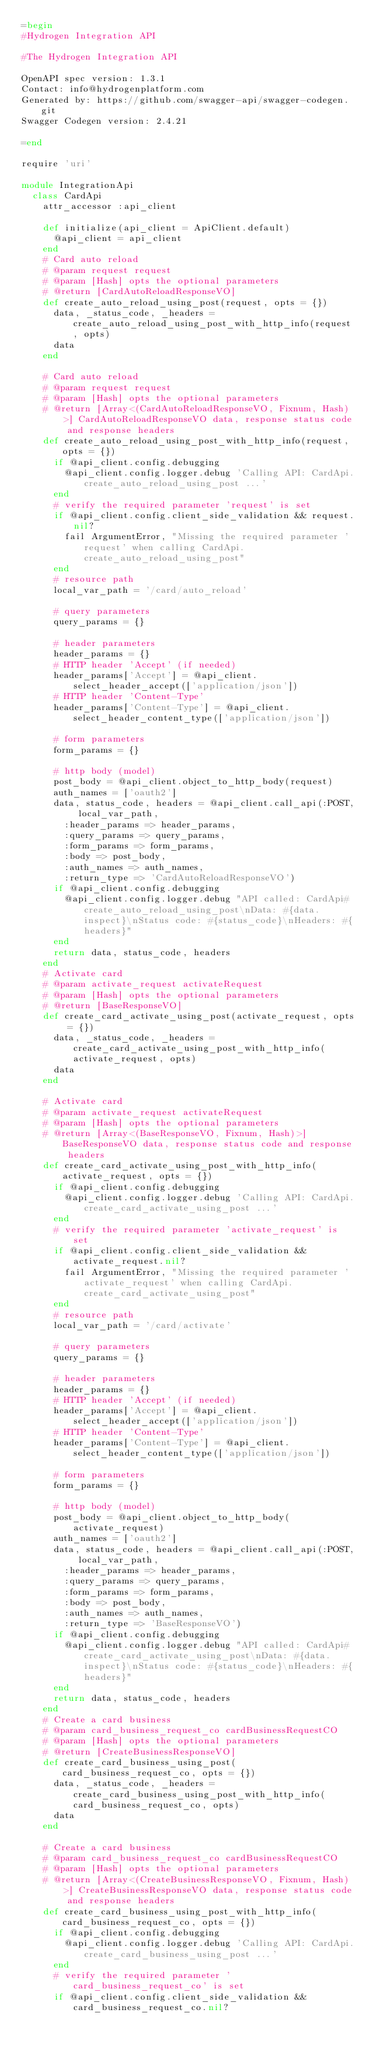Convert code to text. <code><loc_0><loc_0><loc_500><loc_500><_Ruby_>=begin
#Hydrogen Integration API

#The Hydrogen Integration API

OpenAPI spec version: 1.3.1
Contact: info@hydrogenplatform.com
Generated by: https://github.com/swagger-api/swagger-codegen.git
Swagger Codegen version: 2.4.21

=end

require 'uri'

module IntegrationApi
  class CardApi
    attr_accessor :api_client

    def initialize(api_client = ApiClient.default)
      @api_client = api_client
    end
    # Card auto reload
    # @param request request
    # @param [Hash] opts the optional parameters
    # @return [CardAutoReloadResponseVO]
    def create_auto_reload_using_post(request, opts = {})
      data, _status_code, _headers = create_auto_reload_using_post_with_http_info(request, opts)
      data
    end

    # Card auto reload
    # @param request request
    # @param [Hash] opts the optional parameters
    # @return [Array<(CardAutoReloadResponseVO, Fixnum, Hash)>] CardAutoReloadResponseVO data, response status code and response headers
    def create_auto_reload_using_post_with_http_info(request, opts = {})
      if @api_client.config.debugging
        @api_client.config.logger.debug 'Calling API: CardApi.create_auto_reload_using_post ...'
      end
      # verify the required parameter 'request' is set
      if @api_client.config.client_side_validation && request.nil?
        fail ArgumentError, "Missing the required parameter 'request' when calling CardApi.create_auto_reload_using_post"
      end
      # resource path
      local_var_path = '/card/auto_reload'

      # query parameters
      query_params = {}

      # header parameters
      header_params = {}
      # HTTP header 'Accept' (if needed)
      header_params['Accept'] = @api_client.select_header_accept(['application/json'])
      # HTTP header 'Content-Type'
      header_params['Content-Type'] = @api_client.select_header_content_type(['application/json'])

      # form parameters
      form_params = {}

      # http body (model)
      post_body = @api_client.object_to_http_body(request)
      auth_names = ['oauth2']
      data, status_code, headers = @api_client.call_api(:POST, local_var_path,
        :header_params => header_params,
        :query_params => query_params,
        :form_params => form_params,
        :body => post_body,
        :auth_names => auth_names,
        :return_type => 'CardAutoReloadResponseVO')
      if @api_client.config.debugging
        @api_client.config.logger.debug "API called: CardApi#create_auto_reload_using_post\nData: #{data.inspect}\nStatus code: #{status_code}\nHeaders: #{headers}"
      end
      return data, status_code, headers
    end
    # Activate card
    # @param activate_request activateRequest
    # @param [Hash] opts the optional parameters
    # @return [BaseResponseVO]
    def create_card_activate_using_post(activate_request, opts = {})
      data, _status_code, _headers = create_card_activate_using_post_with_http_info(activate_request, opts)
      data
    end

    # Activate card
    # @param activate_request activateRequest
    # @param [Hash] opts the optional parameters
    # @return [Array<(BaseResponseVO, Fixnum, Hash)>] BaseResponseVO data, response status code and response headers
    def create_card_activate_using_post_with_http_info(activate_request, opts = {})
      if @api_client.config.debugging
        @api_client.config.logger.debug 'Calling API: CardApi.create_card_activate_using_post ...'
      end
      # verify the required parameter 'activate_request' is set
      if @api_client.config.client_side_validation && activate_request.nil?
        fail ArgumentError, "Missing the required parameter 'activate_request' when calling CardApi.create_card_activate_using_post"
      end
      # resource path
      local_var_path = '/card/activate'

      # query parameters
      query_params = {}

      # header parameters
      header_params = {}
      # HTTP header 'Accept' (if needed)
      header_params['Accept'] = @api_client.select_header_accept(['application/json'])
      # HTTP header 'Content-Type'
      header_params['Content-Type'] = @api_client.select_header_content_type(['application/json'])

      # form parameters
      form_params = {}

      # http body (model)
      post_body = @api_client.object_to_http_body(activate_request)
      auth_names = ['oauth2']
      data, status_code, headers = @api_client.call_api(:POST, local_var_path,
        :header_params => header_params,
        :query_params => query_params,
        :form_params => form_params,
        :body => post_body,
        :auth_names => auth_names,
        :return_type => 'BaseResponseVO')
      if @api_client.config.debugging
        @api_client.config.logger.debug "API called: CardApi#create_card_activate_using_post\nData: #{data.inspect}\nStatus code: #{status_code}\nHeaders: #{headers}"
      end
      return data, status_code, headers
    end
    # Create a card business
    # @param card_business_request_co cardBusinessRequestCO
    # @param [Hash] opts the optional parameters
    # @return [CreateBusinessResponseVO]
    def create_card_business_using_post(card_business_request_co, opts = {})
      data, _status_code, _headers = create_card_business_using_post_with_http_info(card_business_request_co, opts)
      data
    end

    # Create a card business
    # @param card_business_request_co cardBusinessRequestCO
    # @param [Hash] opts the optional parameters
    # @return [Array<(CreateBusinessResponseVO, Fixnum, Hash)>] CreateBusinessResponseVO data, response status code and response headers
    def create_card_business_using_post_with_http_info(card_business_request_co, opts = {})
      if @api_client.config.debugging
        @api_client.config.logger.debug 'Calling API: CardApi.create_card_business_using_post ...'
      end
      # verify the required parameter 'card_business_request_co' is set
      if @api_client.config.client_side_validation && card_business_request_co.nil?</code> 